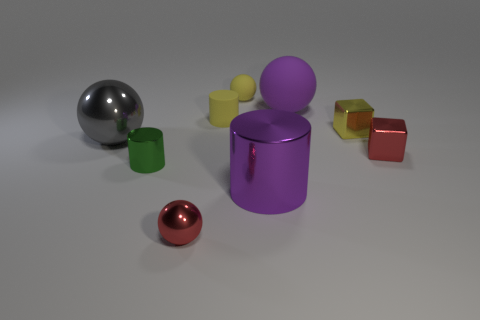What shape is the small metallic object that is the same color as the small rubber cylinder?
Give a very brief answer. Cube. There is a object that is in front of the green cylinder and on the left side of the large purple cylinder; what is its material?
Offer a terse response. Metal. Is the size of the red metal sphere to the right of the green metallic cylinder the same as the yellow block?
Your answer should be very brief. Yes. Is the tiny metal ball the same color as the big shiny cylinder?
Your answer should be compact. No. What number of shiny things are both in front of the tiny green metal object and on the left side of the yellow matte ball?
Make the answer very short. 1. What number of purple things are in front of the tiny ball that is behind the purple thing that is behind the tiny green metallic object?
Offer a very short reply. 2. There is a thing that is the same color as the large matte sphere; what size is it?
Ensure brevity in your answer.  Large. The green object is what shape?
Your answer should be very brief. Cylinder. What number of yellow spheres have the same material as the green cylinder?
Your answer should be compact. 0. The tiny ball that is made of the same material as the small red block is what color?
Provide a succinct answer. Red. 